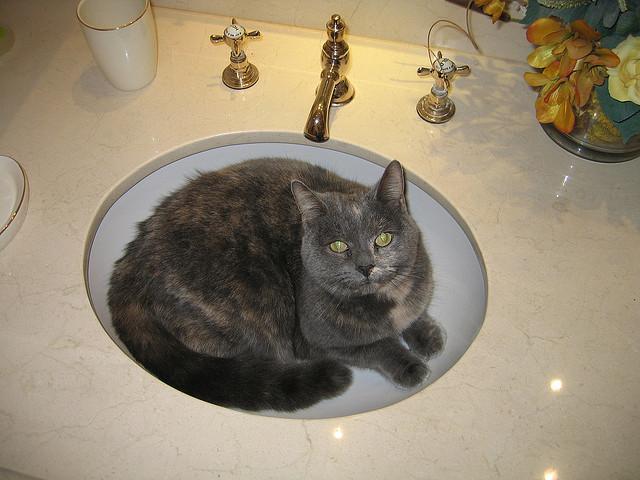Why should this cat be scared?
Select the correct answer and articulate reasoning with the following format: 'Answer: answer
Rationale: rationale.'
Options: Water, fire, noise, physical harm. Answer: water.
Rationale: It is in a sink with a faucet 